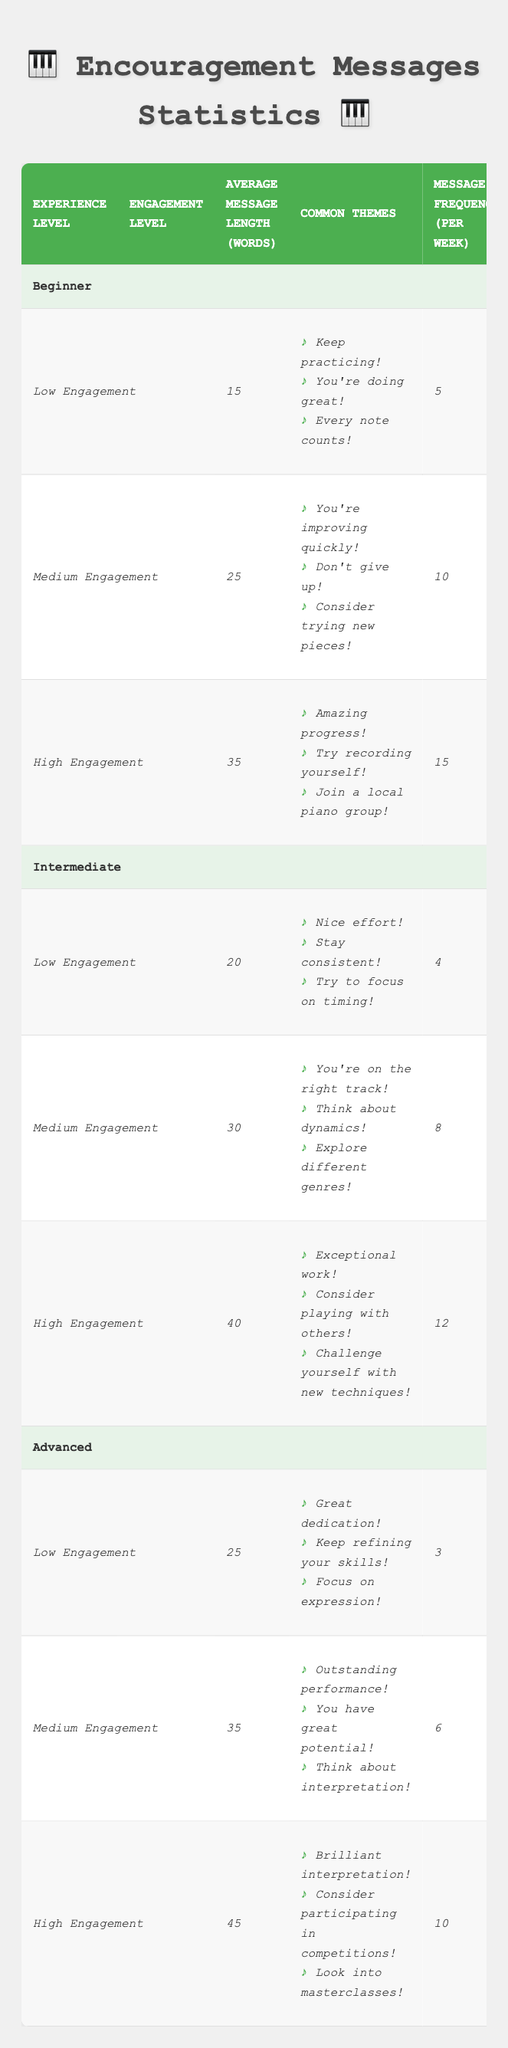What is the average message length for beginners with medium engagement? According to the table, under the Beginner category and Medium Engagement, the Average Message Length is 25 words.
Answer: 25 How many common themes are listed for advanced pianists with high engagement? There are three common themes listed for Advanced pianists with High Engagement. They are: "Brilliant interpretation!", "Consider participating in competitions!", and "Look into masterclasses!".
Answer: 3 What is the total message frequency for intermediate pianists across all engagement levels? The total message frequency for Intermediate pianists is calculated by summing the frequencies across the engagement levels: Low (4) + Medium (8) + High (12) = 24.
Answer: 24 Is the Average Message Length higher for Intermediate pianists with High Engagement compared to Beginner pianists with High Engagement? Yes, the Average Message Length for Intermediate pianists with High Engagement is 40 words, while for Beginner pianists with High Engagement, it is 35 words.
Answer: Yes How does the Average Message Length for Advanced pianists with Low Engagement compare to that of Intermediate pianists with Low Engagement? The Average Message Length for Advanced pianists with Low Engagement is 25 words, while for Intermediate pianists with Low Engagement, it is 20 words, indicating that Advanced pianists have a longer message length.
Answer: Advanced pianists have a longer message length 